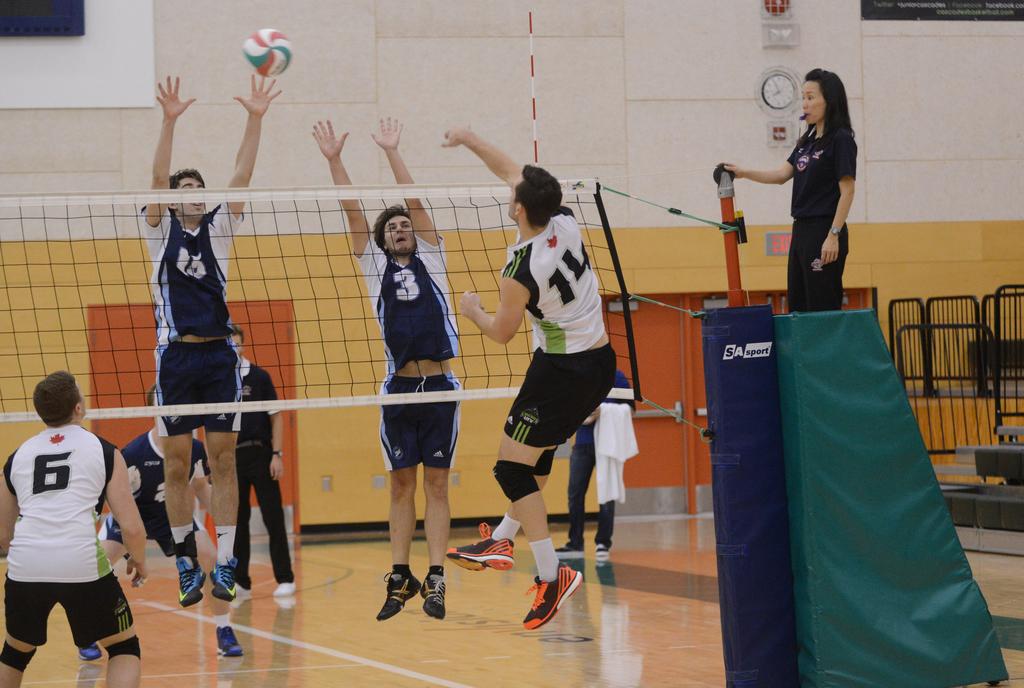What is the number of the person in the white shirt who did not jump?
Offer a very short reply. 6. What kind of ball is that?
Provide a short and direct response. Answering does not require reading text in the image. 